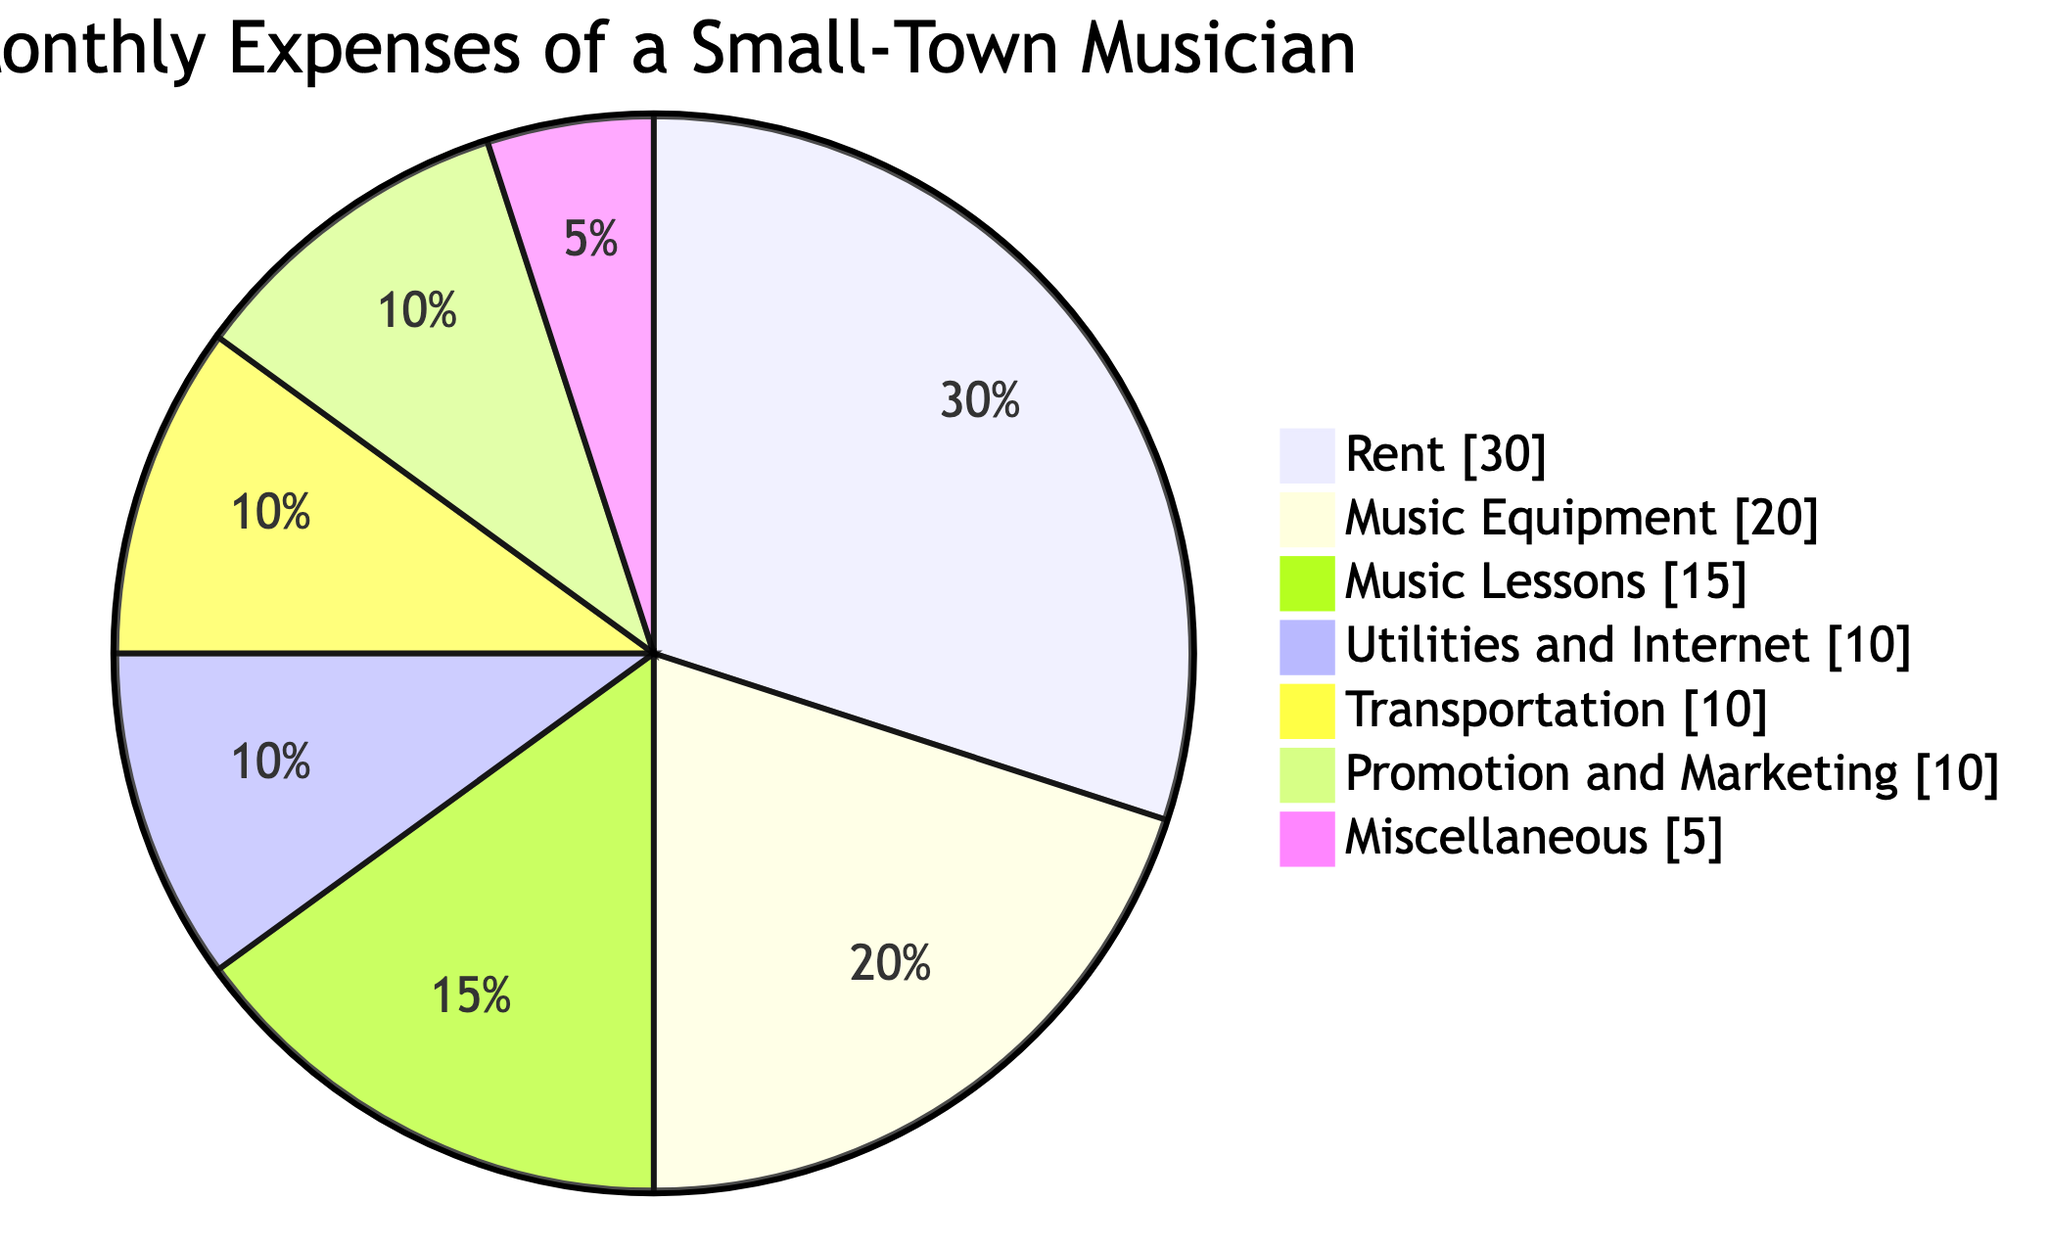What is the largest category of monthly expenses? The diagram shows that "Rent" is the largest category, making up 30% of the total expenses.
Answer: Rent How much do monthly music lessons cost? The cost of "Music Lessons" is clearly indicated as 15%.
Answer: 15 What percentage of the budget is allocated to music equipment? The diagram indicates that "Music Equipment" accounts for 20% of the monthly expenses.
Answer: 20 Which two categories have the same expense percentage? "Transportation" and "Promotion and Marketing" both have an expense of 10%, which is the same.
Answer: Transportation and Promotion and Marketing What is the total percentage of miscellaneous expenses and utilities? Adding "Miscellaneous" (5%) and "Utilities and Internet" (10%), the total percentage is 15%.
Answer: 15 If the musician wanted to reduce expenses, which category could they cut down on the most? The "Miscellaneous" category, being only 5%, is the smallest and therefore the most cuttable.
Answer: Miscellaneous How many expense categories are represented in the diagram? The diagram lists a total of 7 different expense categories.
Answer: 7 What other category is equal in percentage to utilities expenses? The expenses for "Promotion and Marketing" also amount to 10%, just like "Utilities and Internet."
Answer: Promotion and Marketing 